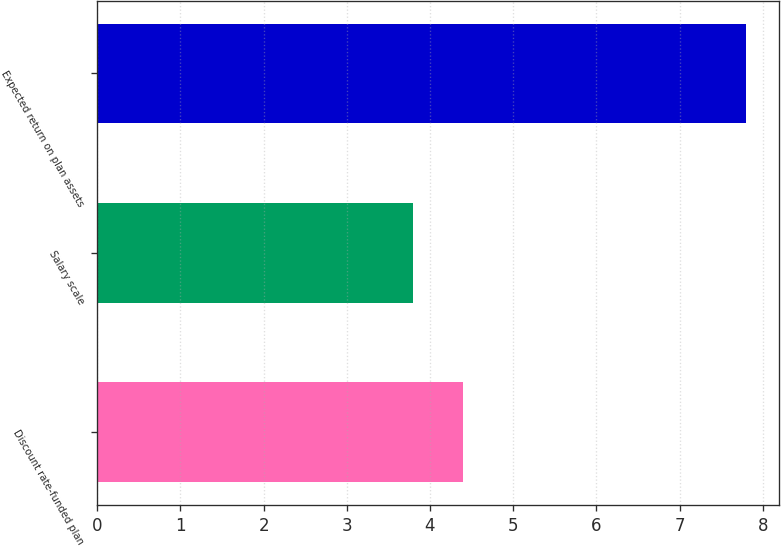<chart> <loc_0><loc_0><loc_500><loc_500><bar_chart><fcel>Discount rate-funded plan<fcel>Salary scale<fcel>Expected return on plan assets<nl><fcel>4.4<fcel>3.8<fcel>7.8<nl></chart> 